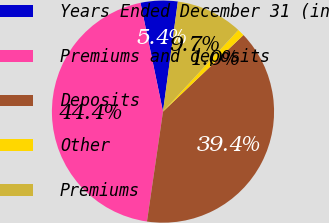<chart> <loc_0><loc_0><loc_500><loc_500><pie_chart><fcel>Years Ended December 31 (in<fcel>Premiums and deposits<fcel>Deposits<fcel>Other<fcel>Premiums<nl><fcel>5.38%<fcel>44.45%<fcel>39.41%<fcel>1.04%<fcel>9.72%<nl></chart> 